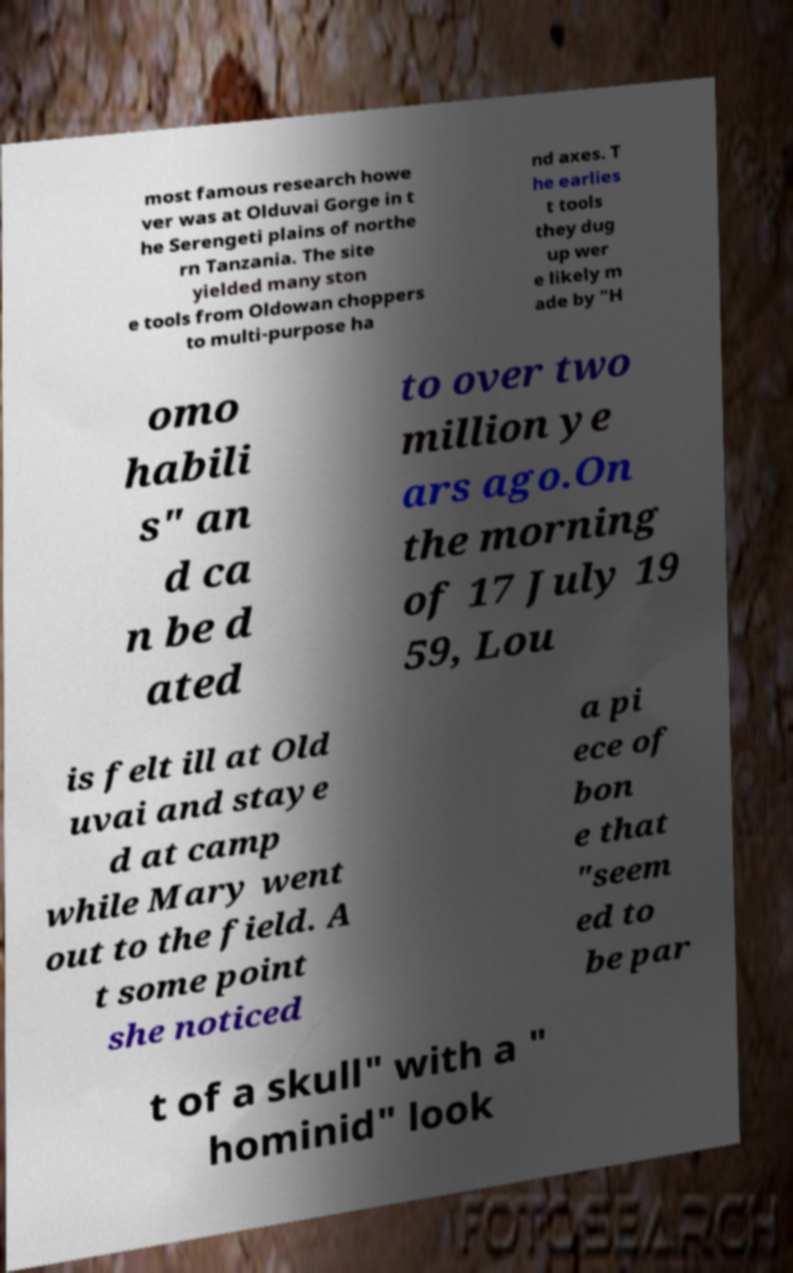For documentation purposes, I need the text within this image transcribed. Could you provide that? most famous research howe ver was at Olduvai Gorge in t he Serengeti plains of northe rn Tanzania. The site yielded many ston e tools from Oldowan choppers to multi-purpose ha nd axes. T he earlies t tools they dug up wer e likely m ade by "H omo habili s" an d ca n be d ated to over two million ye ars ago.On the morning of 17 July 19 59, Lou is felt ill at Old uvai and staye d at camp while Mary went out to the field. A t some point she noticed a pi ece of bon e that "seem ed to be par t of a skull" with a " hominid" look 